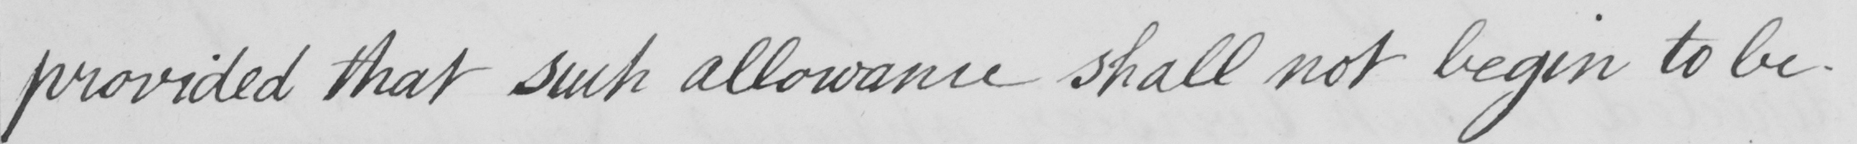Please transcribe the handwritten text in this image. provided that such allowance shall not begin to be- 